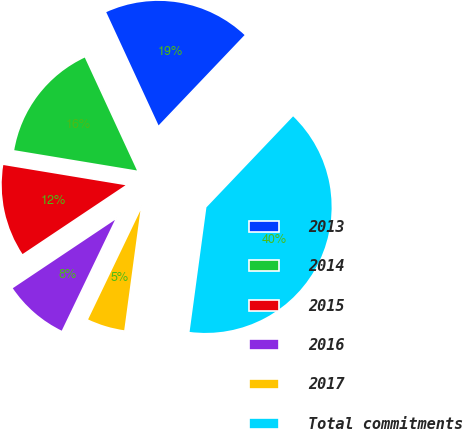Convert chart. <chart><loc_0><loc_0><loc_500><loc_500><pie_chart><fcel>2013<fcel>2014<fcel>2015<fcel>2016<fcel>2017<fcel>Total commitments<nl><fcel>19.0%<fcel>15.5%<fcel>11.99%<fcel>8.49%<fcel>4.99%<fcel>40.03%<nl></chart> 